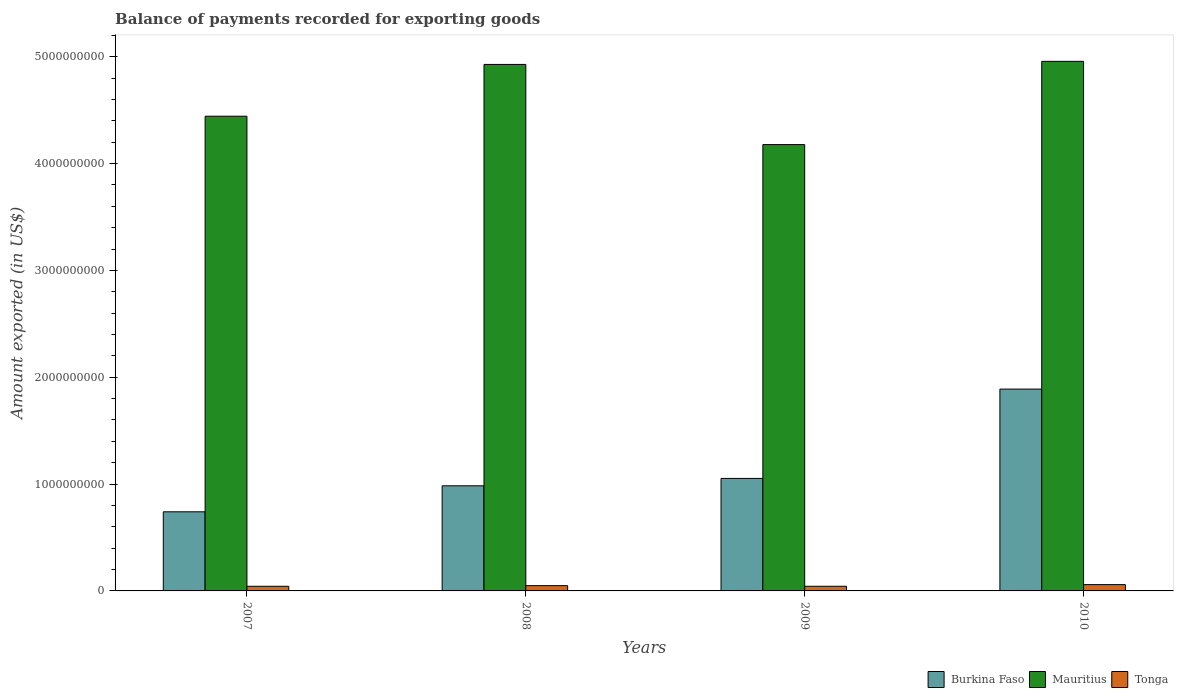How many different coloured bars are there?
Give a very brief answer. 3. How many groups of bars are there?
Keep it short and to the point. 4. Are the number of bars per tick equal to the number of legend labels?
Provide a succinct answer. Yes. Are the number of bars on each tick of the X-axis equal?
Ensure brevity in your answer.  Yes. How many bars are there on the 2nd tick from the left?
Provide a short and direct response. 3. How many bars are there on the 3rd tick from the right?
Ensure brevity in your answer.  3. What is the label of the 2nd group of bars from the left?
Make the answer very short. 2008. In how many cases, is the number of bars for a given year not equal to the number of legend labels?
Your answer should be very brief. 0. What is the amount exported in Tonga in 2009?
Ensure brevity in your answer.  4.35e+07. Across all years, what is the maximum amount exported in Burkina Faso?
Your answer should be compact. 1.89e+09. Across all years, what is the minimum amount exported in Mauritius?
Offer a very short reply. 4.18e+09. In which year was the amount exported in Burkina Faso maximum?
Ensure brevity in your answer.  2010. In which year was the amount exported in Mauritius minimum?
Offer a very short reply. 2009. What is the total amount exported in Tonga in the graph?
Your response must be concise. 1.95e+08. What is the difference between the amount exported in Burkina Faso in 2007 and that in 2009?
Provide a short and direct response. -3.12e+08. What is the difference between the amount exported in Tonga in 2007 and the amount exported in Mauritius in 2010?
Provide a short and direct response. -4.91e+09. What is the average amount exported in Burkina Faso per year?
Offer a very short reply. 1.17e+09. In the year 2007, what is the difference between the amount exported in Burkina Faso and amount exported in Mauritius?
Make the answer very short. -3.70e+09. In how many years, is the amount exported in Tonga greater than 2200000000 US$?
Keep it short and to the point. 0. What is the ratio of the amount exported in Mauritius in 2007 to that in 2010?
Your answer should be compact. 0.9. Is the amount exported in Mauritius in 2008 less than that in 2010?
Make the answer very short. Yes. What is the difference between the highest and the second highest amount exported in Mauritius?
Make the answer very short. 2.88e+07. What is the difference between the highest and the lowest amount exported in Tonga?
Ensure brevity in your answer.  1.56e+07. What does the 1st bar from the left in 2010 represents?
Provide a succinct answer. Burkina Faso. What does the 1st bar from the right in 2009 represents?
Your answer should be compact. Tonga. Does the graph contain any zero values?
Keep it short and to the point. No. Does the graph contain grids?
Make the answer very short. No. Where does the legend appear in the graph?
Your response must be concise. Bottom right. What is the title of the graph?
Give a very brief answer. Balance of payments recorded for exporting goods. Does "Egypt, Arab Rep." appear as one of the legend labels in the graph?
Your answer should be very brief. No. What is the label or title of the Y-axis?
Keep it short and to the point. Amount exported (in US$). What is the Amount exported (in US$) of Burkina Faso in 2007?
Offer a terse response. 7.41e+08. What is the Amount exported (in US$) of Mauritius in 2007?
Your answer should be very brief. 4.44e+09. What is the Amount exported (in US$) of Tonga in 2007?
Provide a short and direct response. 4.34e+07. What is the Amount exported (in US$) of Burkina Faso in 2008?
Keep it short and to the point. 9.84e+08. What is the Amount exported (in US$) in Mauritius in 2008?
Your response must be concise. 4.93e+09. What is the Amount exported (in US$) of Tonga in 2008?
Your answer should be very brief. 4.93e+07. What is the Amount exported (in US$) in Burkina Faso in 2009?
Ensure brevity in your answer.  1.05e+09. What is the Amount exported (in US$) in Mauritius in 2009?
Provide a succinct answer. 4.18e+09. What is the Amount exported (in US$) in Tonga in 2009?
Provide a short and direct response. 4.35e+07. What is the Amount exported (in US$) in Burkina Faso in 2010?
Your answer should be compact. 1.89e+09. What is the Amount exported (in US$) in Mauritius in 2010?
Offer a very short reply. 4.96e+09. What is the Amount exported (in US$) in Tonga in 2010?
Your response must be concise. 5.90e+07. Across all years, what is the maximum Amount exported (in US$) in Burkina Faso?
Make the answer very short. 1.89e+09. Across all years, what is the maximum Amount exported (in US$) of Mauritius?
Your answer should be very brief. 4.96e+09. Across all years, what is the maximum Amount exported (in US$) of Tonga?
Your answer should be very brief. 5.90e+07. Across all years, what is the minimum Amount exported (in US$) of Burkina Faso?
Make the answer very short. 7.41e+08. Across all years, what is the minimum Amount exported (in US$) in Mauritius?
Make the answer very short. 4.18e+09. Across all years, what is the minimum Amount exported (in US$) of Tonga?
Your answer should be compact. 4.34e+07. What is the total Amount exported (in US$) of Burkina Faso in the graph?
Ensure brevity in your answer.  4.67e+09. What is the total Amount exported (in US$) in Mauritius in the graph?
Offer a very short reply. 1.85e+1. What is the total Amount exported (in US$) of Tonga in the graph?
Provide a short and direct response. 1.95e+08. What is the difference between the Amount exported (in US$) of Burkina Faso in 2007 and that in 2008?
Provide a succinct answer. -2.43e+08. What is the difference between the Amount exported (in US$) of Mauritius in 2007 and that in 2008?
Provide a short and direct response. -4.85e+08. What is the difference between the Amount exported (in US$) in Tonga in 2007 and that in 2008?
Your response must be concise. -5.97e+06. What is the difference between the Amount exported (in US$) in Burkina Faso in 2007 and that in 2009?
Your answer should be very brief. -3.12e+08. What is the difference between the Amount exported (in US$) in Mauritius in 2007 and that in 2009?
Ensure brevity in your answer.  2.66e+08. What is the difference between the Amount exported (in US$) in Tonga in 2007 and that in 2009?
Provide a succinct answer. -1.01e+05. What is the difference between the Amount exported (in US$) in Burkina Faso in 2007 and that in 2010?
Your answer should be very brief. -1.15e+09. What is the difference between the Amount exported (in US$) in Mauritius in 2007 and that in 2010?
Provide a short and direct response. -5.14e+08. What is the difference between the Amount exported (in US$) of Tonga in 2007 and that in 2010?
Your answer should be compact. -1.56e+07. What is the difference between the Amount exported (in US$) in Burkina Faso in 2008 and that in 2009?
Your answer should be compact. -6.92e+07. What is the difference between the Amount exported (in US$) of Mauritius in 2008 and that in 2009?
Your answer should be compact. 7.50e+08. What is the difference between the Amount exported (in US$) in Tonga in 2008 and that in 2009?
Your response must be concise. 5.87e+06. What is the difference between the Amount exported (in US$) in Burkina Faso in 2008 and that in 2010?
Offer a terse response. -9.05e+08. What is the difference between the Amount exported (in US$) of Mauritius in 2008 and that in 2010?
Provide a short and direct response. -2.88e+07. What is the difference between the Amount exported (in US$) in Tonga in 2008 and that in 2010?
Offer a very short reply. -9.67e+06. What is the difference between the Amount exported (in US$) in Burkina Faso in 2009 and that in 2010?
Keep it short and to the point. -8.36e+08. What is the difference between the Amount exported (in US$) in Mauritius in 2009 and that in 2010?
Keep it short and to the point. -7.79e+08. What is the difference between the Amount exported (in US$) of Tonga in 2009 and that in 2010?
Provide a succinct answer. -1.55e+07. What is the difference between the Amount exported (in US$) in Burkina Faso in 2007 and the Amount exported (in US$) in Mauritius in 2008?
Provide a short and direct response. -4.19e+09. What is the difference between the Amount exported (in US$) in Burkina Faso in 2007 and the Amount exported (in US$) in Tonga in 2008?
Offer a very short reply. 6.91e+08. What is the difference between the Amount exported (in US$) of Mauritius in 2007 and the Amount exported (in US$) of Tonga in 2008?
Provide a short and direct response. 4.39e+09. What is the difference between the Amount exported (in US$) in Burkina Faso in 2007 and the Amount exported (in US$) in Mauritius in 2009?
Your answer should be compact. -3.44e+09. What is the difference between the Amount exported (in US$) in Burkina Faso in 2007 and the Amount exported (in US$) in Tonga in 2009?
Ensure brevity in your answer.  6.97e+08. What is the difference between the Amount exported (in US$) of Mauritius in 2007 and the Amount exported (in US$) of Tonga in 2009?
Your response must be concise. 4.40e+09. What is the difference between the Amount exported (in US$) of Burkina Faso in 2007 and the Amount exported (in US$) of Mauritius in 2010?
Provide a succinct answer. -4.22e+09. What is the difference between the Amount exported (in US$) of Burkina Faso in 2007 and the Amount exported (in US$) of Tonga in 2010?
Make the answer very short. 6.82e+08. What is the difference between the Amount exported (in US$) of Mauritius in 2007 and the Amount exported (in US$) of Tonga in 2010?
Your response must be concise. 4.38e+09. What is the difference between the Amount exported (in US$) in Burkina Faso in 2008 and the Amount exported (in US$) in Mauritius in 2009?
Make the answer very short. -3.19e+09. What is the difference between the Amount exported (in US$) in Burkina Faso in 2008 and the Amount exported (in US$) in Tonga in 2009?
Your answer should be very brief. 9.40e+08. What is the difference between the Amount exported (in US$) of Mauritius in 2008 and the Amount exported (in US$) of Tonga in 2009?
Your response must be concise. 4.88e+09. What is the difference between the Amount exported (in US$) of Burkina Faso in 2008 and the Amount exported (in US$) of Mauritius in 2010?
Your response must be concise. -3.97e+09. What is the difference between the Amount exported (in US$) of Burkina Faso in 2008 and the Amount exported (in US$) of Tonga in 2010?
Provide a short and direct response. 9.25e+08. What is the difference between the Amount exported (in US$) in Mauritius in 2008 and the Amount exported (in US$) in Tonga in 2010?
Make the answer very short. 4.87e+09. What is the difference between the Amount exported (in US$) of Burkina Faso in 2009 and the Amount exported (in US$) of Mauritius in 2010?
Your answer should be compact. -3.90e+09. What is the difference between the Amount exported (in US$) of Burkina Faso in 2009 and the Amount exported (in US$) of Tonga in 2010?
Ensure brevity in your answer.  9.94e+08. What is the difference between the Amount exported (in US$) in Mauritius in 2009 and the Amount exported (in US$) in Tonga in 2010?
Your answer should be compact. 4.12e+09. What is the average Amount exported (in US$) of Burkina Faso per year?
Your answer should be very brief. 1.17e+09. What is the average Amount exported (in US$) in Mauritius per year?
Keep it short and to the point. 4.63e+09. What is the average Amount exported (in US$) in Tonga per year?
Ensure brevity in your answer.  4.88e+07. In the year 2007, what is the difference between the Amount exported (in US$) of Burkina Faso and Amount exported (in US$) of Mauritius?
Provide a succinct answer. -3.70e+09. In the year 2007, what is the difference between the Amount exported (in US$) in Burkina Faso and Amount exported (in US$) in Tonga?
Give a very brief answer. 6.97e+08. In the year 2007, what is the difference between the Amount exported (in US$) of Mauritius and Amount exported (in US$) of Tonga?
Keep it short and to the point. 4.40e+09. In the year 2008, what is the difference between the Amount exported (in US$) in Burkina Faso and Amount exported (in US$) in Mauritius?
Offer a very short reply. -3.94e+09. In the year 2008, what is the difference between the Amount exported (in US$) in Burkina Faso and Amount exported (in US$) in Tonga?
Your answer should be compact. 9.35e+08. In the year 2008, what is the difference between the Amount exported (in US$) of Mauritius and Amount exported (in US$) of Tonga?
Keep it short and to the point. 4.88e+09. In the year 2009, what is the difference between the Amount exported (in US$) in Burkina Faso and Amount exported (in US$) in Mauritius?
Offer a very short reply. -3.12e+09. In the year 2009, what is the difference between the Amount exported (in US$) in Burkina Faso and Amount exported (in US$) in Tonga?
Your answer should be compact. 1.01e+09. In the year 2009, what is the difference between the Amount exported (in US$) of Mauritius and Amount exported (in US$) of Tonga?
Keep it short and to the point. 4.13e+09. In the year 2010, what is the difference between the Amount exported (in US$) of Burkina Faso and Amount exported (in US$) of Mauritius?
Your answer should be compact. -3.07e+09. In the year 2010, what is the difference between the Amount exported (in US$) in Burkina Faso and Amount exported (in US$) in Tonga?
Ensure brevity in your answer.  1.83e+09. In the year 2010, what is the difference between the Amount exported (in US$) in Mauritius and Amount exported (in US$) in Tonga?
Offer a terse response. 4.90e+09. What is the ratio of the Amount exported (in US$) in Burkina Faso in 2007 to that in 2008?
Provide a succinct answer. 0.75. What is the ratio of the Amount exported (in US$) in Mauritius in 2007 to that in 2008?
Provide a succinct answer. 0.9. What is the ratio of the Amount exported (in US$) in Tonga in 2007 to that in 2008?
Give a very brief answer. 0.88. What is the ratio of the Amount exported (in US$) in Burkina Faso in 2007 to that in 2009?
Your response must be concise. 0.7. What is the ratio of the Amount exported (in US$) in Mauritius in 2007 to that in 2009?
Your answer should be very brief. 1.06. What is the ratio of the Amount exported (in US$) in Burkina Faso in 2007 to that in 2010?
Keep it short and to the point. 0.39. What is the ratio of the Amount exported (in US$) of Mauritius in 2007 to that in 2010?
Make the answer very short. 0.9. What is the ratio of the Amount exported (in US$) of Tonga in 2007 to that in 2010?
Give a very brief answer. 0.73. What is the ratio of the Amount exported (in US$) in Burkina Faso in 2008 to that in 2009?
Give a very brief answer. 0.93. What is the ratio of the Amount exported (in US$) in Mauritius in 2008 to that in 2009?
Give a very brief answer. 1.18. What is the ratio of the Amount exported (in US$) in Tonga in 2008 to that in 2009?
Your response must be concise. 1.14. What is the ratio of the Amount exported (in US$) of Burkina Faso in 2008 to that in 2010?
Give a very brief answer. 0.52. What is the ratio of the Amount exported (in US$) of Tonga in 2008 to that in 2010?
Your answer should be compact. 0.84. What is the ratio of the Amount exported (in US$) of Burkina Faso in 2009 to that in 2010?
Your response must be concise. 0.56. What is the ratio of the Amount exported (in US$) in Mauritius in 2009 to that in 2010?
Give a very brief answer. 0.84. What is the ratio of the Amount exported (in US$) of Tonga in 2009 to that in 2010?
Give a very brief answer. 0.74. What is the difference between the highest and the second highest Amount exported (in US$) of Burkina Faso?
Make the answer very short. 8.36e+08. What is the difference between the highest and the second highest Amount exported (in US$) in Mauritius?
Your answer should be very brief. 2.88e+07. What is the difference between the highest and the second highest Amount exported (in US$) of Tonga?
Offer a very short reply. 9.67e+06. What is the difference between the highest and the lowest Amount exported (in US$) in Burkina Faso?
Your answer should be very brief. 1.15e+09. What is the difference between the highest and the lowest Amount exported (in US$) in Mauritius?
Offer a terse response. 7.79e+08. What is the difference between the highest and the lowest Amount exported (in US$) of Tonga?
Your answer should be very brief. 1.56e+07. 